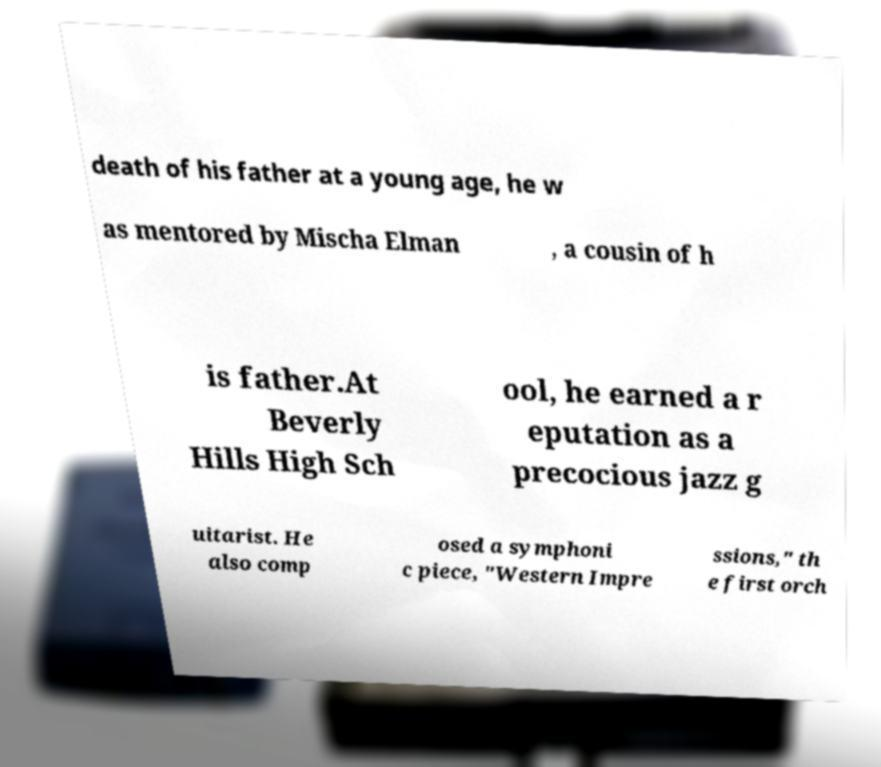Please read and relay the text visible in this image. What does it say? death of his father at a young age, he w as mentored by Mischa Elman , a cousin of h is father.At Beverly Hills High Sch ool, he earned a r eputation as a precocious jazz g uitarist. He also comp osed a symphoni c piece, "Western Impre ssions," th e first orch 